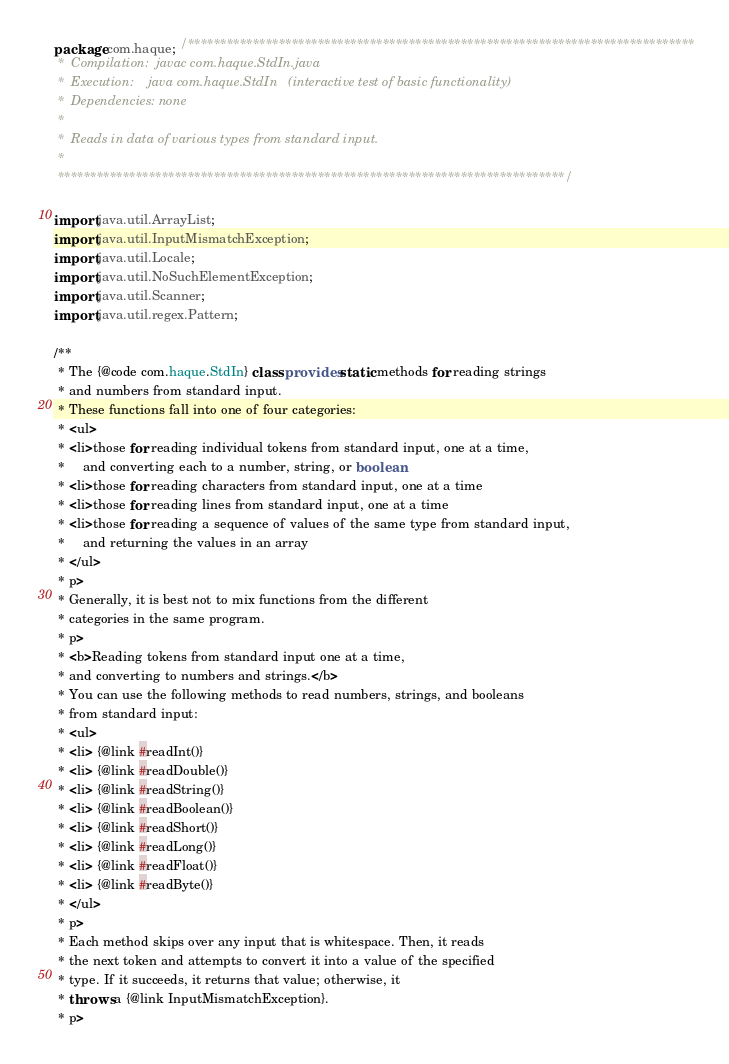Convert code to text. <code><loc_0><loc_0><loc_500><loc_500><_Java_>package com.haque; /******************************************************************************
 *  Compilation:  javac com.haque.StdIn.java
 *  Execution:    java com.haque.StdIn   (interactive test of basic functionality)
 *  Dependencies: none
 *
 *  Reads in data of various types from standard input.
 *
 ******************************************************************************/

import java.util.ArrayList;
import java.util.InputMismatchException;
import java.util.Locale;
import java.util.NoSuchElementException;
import java.util.Scanner;
import java.util.regex.Pattern;

/**
 * The {@code com.haque.StdIn} class provides static methods for reading strings
 * and numbers from standard input.
 * These functions fall into one of four categories:
 * <ul>
 * <li>those for reading individual tokens from standard input, one at a time,
 *     and converting each to a number, string, or boolean
 * <li>those for reading characters from standard input, one at a time
 * <li>those for reading lines from standard input, one at a time
 * <li>those for reading a sequence of values of the same type from standard input,
 *     and returning the values in an array
 * </ul>
 * p>
 * Generally, it is best not to mix functions from the different
 * categories in the same program.
 * p>
 * <b>Reading tokens from standard input one at a time,
 * and converting to numbers and strings.</b>
 * You can use the following methods to read numbers, strings, and booleans
 * from standard input:
 * <ul>
 * <li> {@link #readInt()}
 * <li> {@link #readDouble()}
 * <li> {@link #readString()}
 * <li> {@link #readBoolean()}
 * <li> {@link #readShort()}
 * <li> {@link #readLong()}
 * <li> {@link #readFloat()}
 * <li> {@link #readByte()}
 * </ul>
 * p>
 * Each method skips over any input that is whitespace. Then, it reads
 * the next token and attempts to convert it into a value of the specified
 * type. If it succeeds, it returns that value; otherwise, it
 * throws a {@link InputMismatchException}.
 * p></code> 